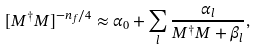Convert formula to latex. <formula><loc_0><loc_0><loc_500><loc_500>[ M ^ { \dag } M ] ^ { - n _ { f } / 4 } \approx \alpha _ { 0 } + \sum _ { l } \frac { \alpha _ { l } } { M ^ { \dag } M + \beta _ { l } } ,</formula> 